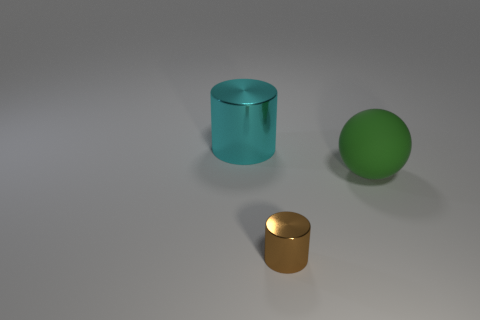Subtract all balls. How many objects are left? 2 Subtract 2 cylinders. How many cylinders are left? 0 Subtract all green cylinders. Subtract all cyan spheres. How many cylinders are left? 2 Subtract all blue balls. How many cyan cylinders are left? 1 Subtract all tiny objects. Subtract all small brown shiny cylinders. How many objects are left? 1 Add 1 big cyan metallic things. How many big cyan metallic things are left? 2 Add 1 brown things. How many brown things exist? 2 Add 3 tiny brown cylinders. How many objects exist? 6 Subtract all cyan cylinders. How many cylinders are left? 1 Subtract 1 green balls. How many objects are left? 2 